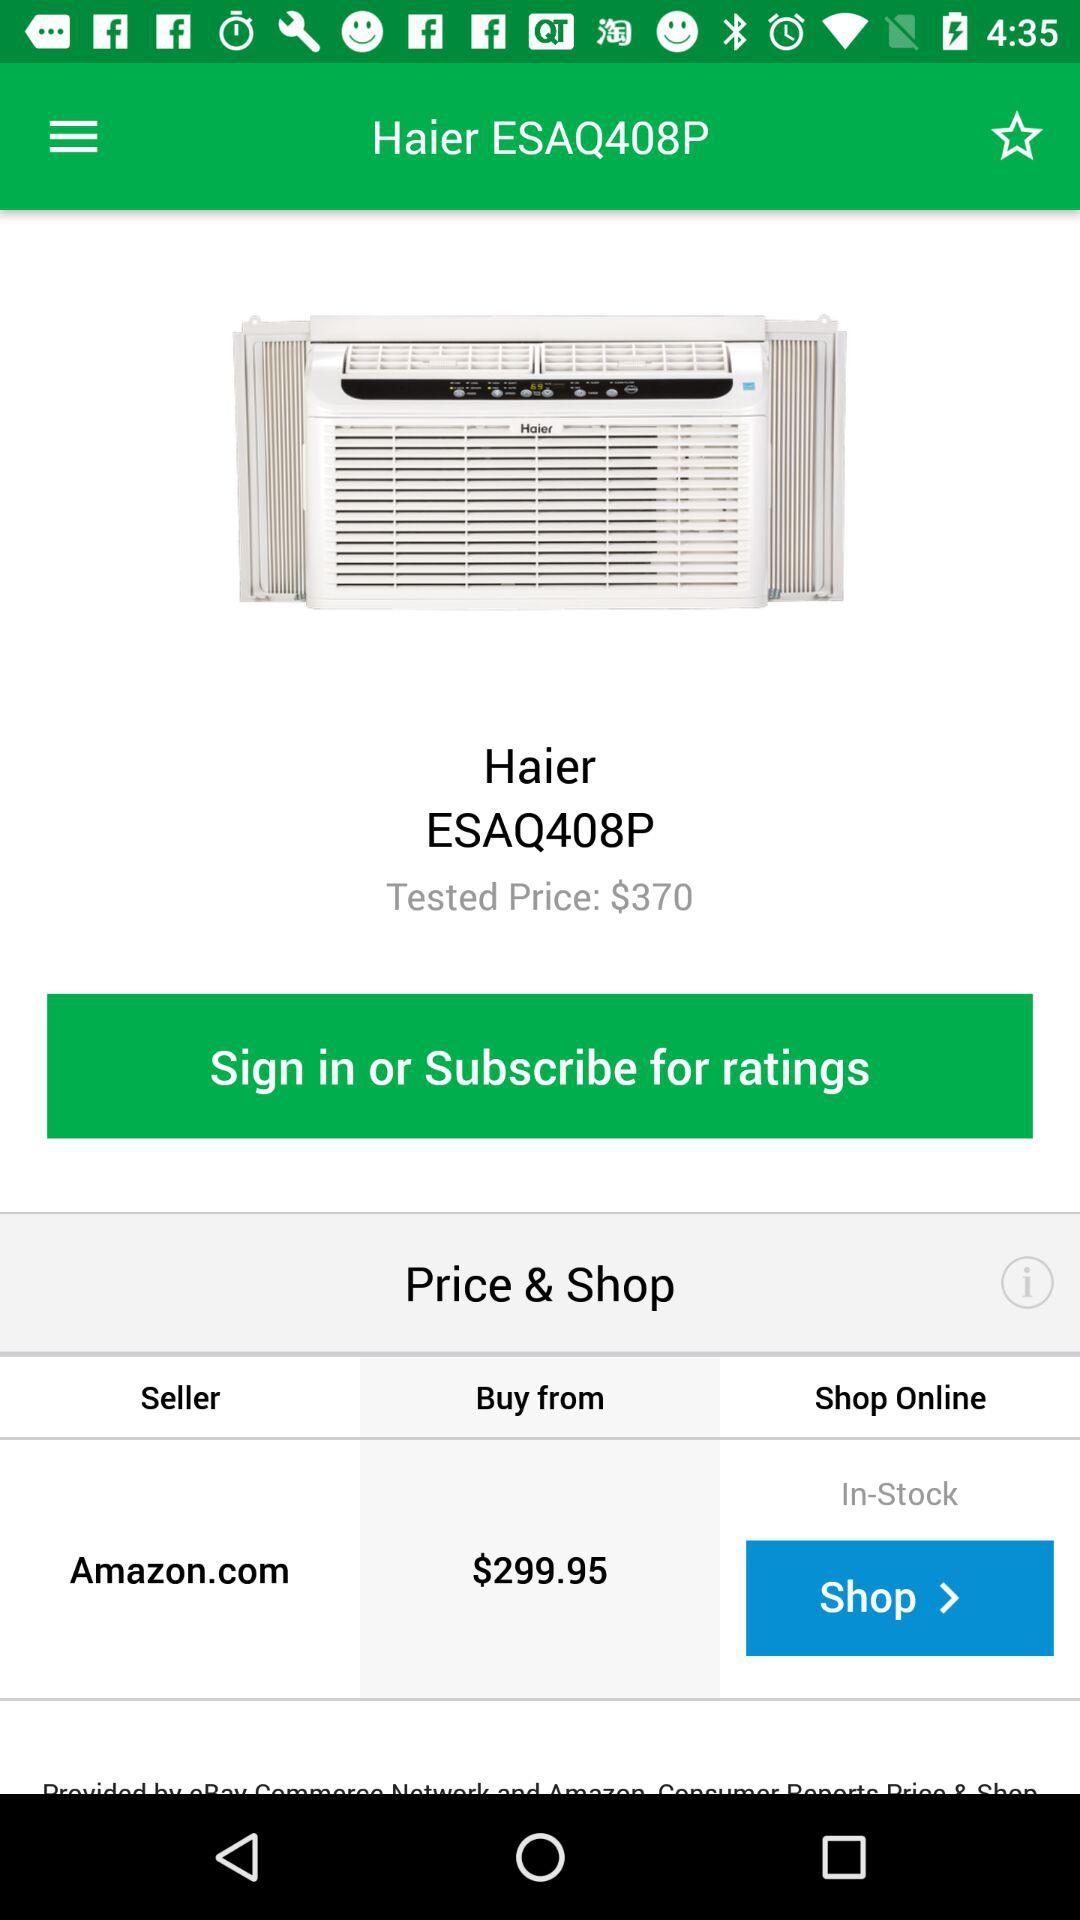What is the product name? The product name is "Haier ESAQ408P". 